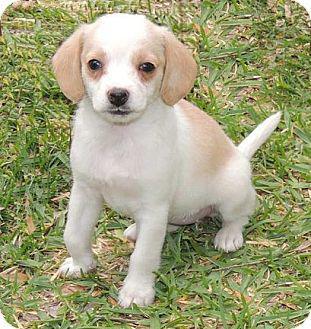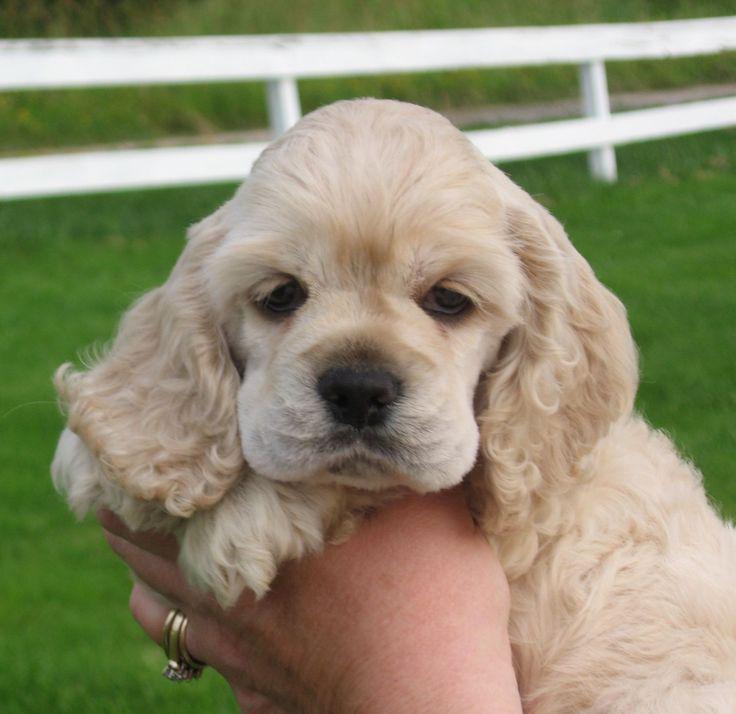The first image is the image on the left, the second image is the image on the right. Analyze the images presented: Is the assertion "The dog in the image on the right is sitting on green grass." valid? Answer yes or no. No. 